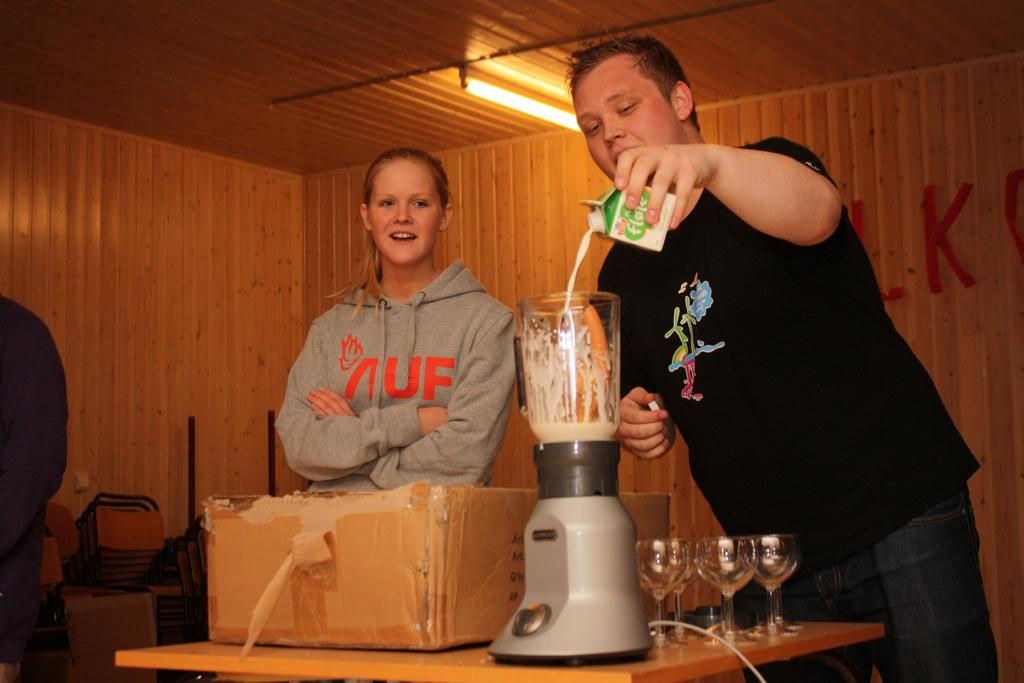Provide a one-sentence caption for the provided image. Two people in a wood paneled room with the girl on the left wearing a grey sweatshirt labeled "UF". 